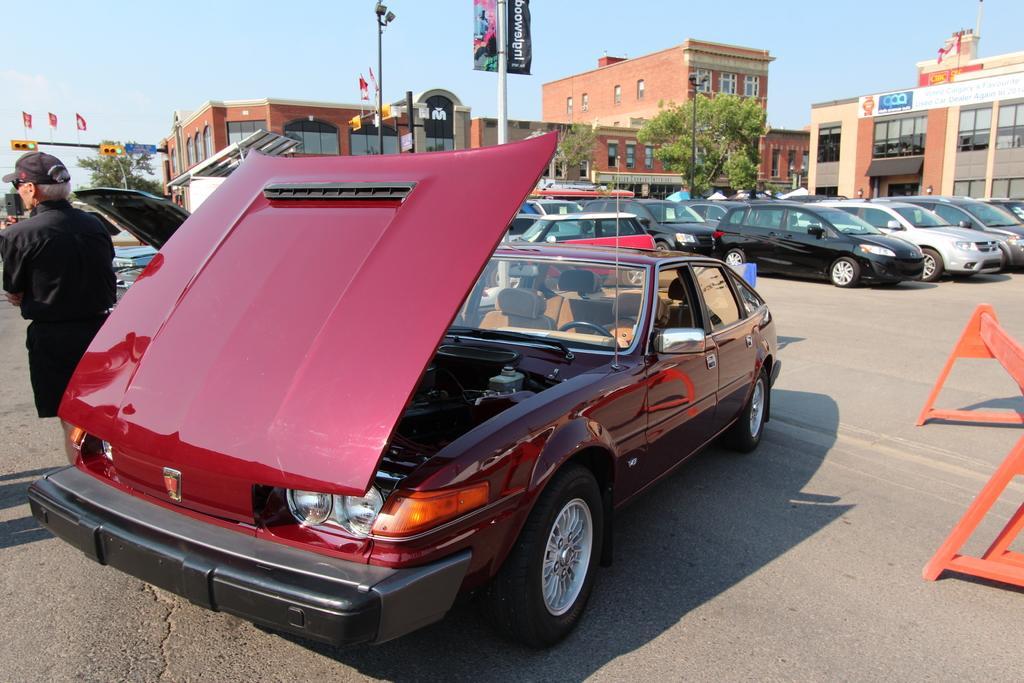Can you describe this image briefly? In the image we can see some vehicles on the road. Behind the vehicles there are some poles and trees and vehicles. On the poles there are some banners. At the top of the image there is sky. On the left side of the image a person is standing. 